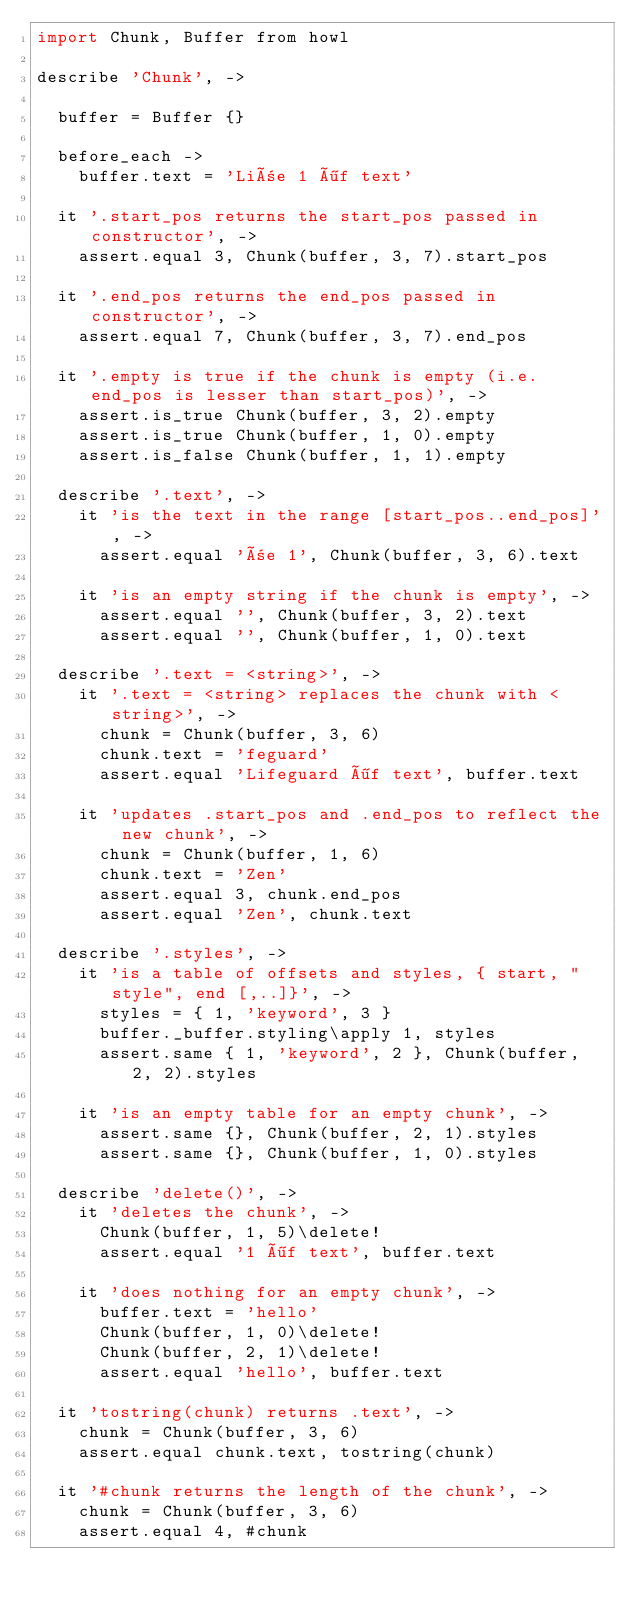Convert code to text. <code><loc_0><loc_0><loc_500><loc_500><_MoonScript_>import Chunk, Buffer from howl

describe 'Chunk', ->

  buffer = Buffer {}

  before_each ->
    buffer.text = 'Liñe 1 öf text'

  it '.start_pos returns the start_pos passed in constructor', ->
    assert.equal 3, Chunk(buffer, 3, 7).start_pos

  it '.end_pos returns the end_pos passed in constructor', ->
    assert.equal 7, Chunk(buffer, 3, 7).end_pos

  it '.empty is true if the chunk is empty (i.e. end_pos is lesser than start_pos)', ->
    assert.is_true Chunk(buffer, 3, 2).empty
    assert.is_true Chunk(buffer, 1, 0).empty
    assert.is_false Chunk(buffer, 1, 1).empty

  describe '.text', ->
    it 'is the text in the range [start_pos..end_pos]', ->
      assert.equal 'ñe 1', Chunk(buffer, 3, 6).text

    it 'is an empty string if the chunk is empty', ->
      assert.equal '', Chunk(buffer, 3, 2).text
      assert.equal '', Chunk(buffer, 1, 0).text

  describe '.text = <string>', ->
    it '.text = <string> replaces the chunk with <string>', ->
      chunk = Chunk(buffer, 3, 6)
      chunk.text = 'feguard'
      assert.equal 'Lifeguard öf text', buffer.text

    it 'updates .start_pos and .end_pos to reflect the new chunk', ->
      chunk = Chunk(buffer, 1, 6)
      chunk.text = 'Zen'
      assert.equal 3, chunk.end_pos
      assert.equal 'Zen', chunk.text

  describe '.styles', ->
    it 'is a table of offsets and styles, { start, "style", end [,..]}', ->
      styles = { 1, 'keyword', 3 }
      buffer._buffer.styling\apply 1, styles
      assert.same { 1, 'keyword', 2 }, Chunk(buffer, 2, 2).styles

    it 'is an empty table for an empty chunk', ->
      assert.same {}, Chunk(buffer, 2, 1).styles
      assert.same {}, Chunk(buffer, 1, 0).styles

  describe 'delete()', ->
    it 'deletes the chunk', ->
      Chunk(buffer, 1, 5)\delete!
      assert.equal '1 öf text', buffer.text

    it 'does nothing for an empty chunk', ->
      buffer.text = 'hello'
      Chunk(buffer, 1, 0)\delete!
      Chunk(buffer, 2, 1)\delete!
      assert.equal 'hello', buffer.text

  it 'tostring(chunk) returns .text', ->
    chunk = Chunk(buffer, 3, 6)
    assert.equal chunk.text, tostring(chunk)

  it '#chunk returns the length of the chunk', ->
    chunk = Chunk(buffer, 3, 6)
    assert.equal 4, #chunk
</code> 